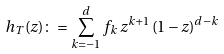Convert formula to latex. <formula><loc_0><loc_0><loc_500><loc_500>h _ { T } ( z ) \colon = \sum _ { k = - 1 } ^ { d } f _ { k } \, z ^ { k + 1 } \, ( 1 - z ) ^ { d - k }</formula> 